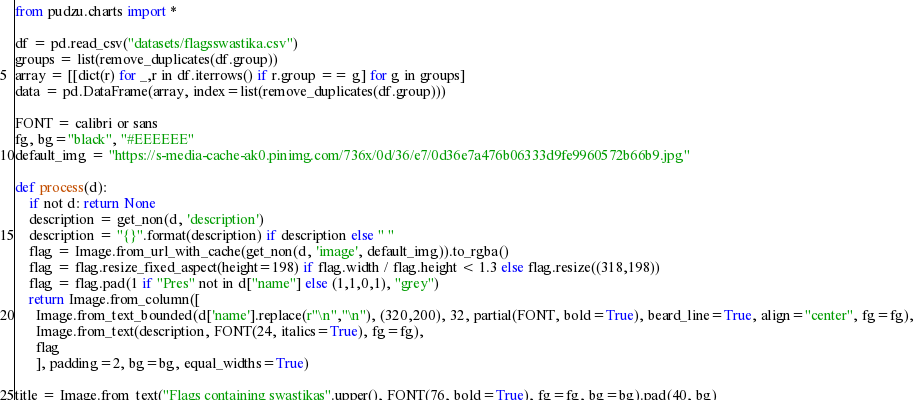Convert code to text. <code><loc_0><loc_0><loc_500><loc_500><_Python_>from pudzu.charts import *

df = pd.read_csv("datasets/flagsswastika.csv")
groups = list(remove_duplicates(df.group))
array = [[dict(r) for _,r in df.iterrows() if r.group == g] for g in groups]
data = pd.DataFrame(array, index=list(remove_duplicates(df.group)))

FONT = calibri or sans
fg, bg="black", "#EEEEEE"
default_img = "https://s-media-cache-ak0.pinimg.com/736x/0d/36/e7/0d36e7a476b06333d9fe9960572b66b9.jpg"

def process(d):
    if not d: return None
    description = get_non(d, 'description')
    description = "{}".format(description) if description else " "
    flag = Image.from_url_with_cache(get_non(d, 'image', default_img)).to_rgba()
    flag = flag.resize_fixed_aspect(height=198) if flag.width / flag.height < 1.3 else flag.resize((318,198))
    flag = flag.pad(1 if "Pres" not in d["name"] else (1,1,0,1), "grey") 
    return Image.from_column([
      Image.from_text_bounded(d['name'].replace(r"\n","\n"), (320,200), 32, partial(FONT, bold=True), beard_line=True, align="center", fg=fg),
      Image.from_text(description, FONT(24, italics=True), fg=fg),
      flag
      ], padding=2, bg=bg, equal_widths=True)

title = Image.from_text("Flags containing swastikas".upper(), FONT(76, bold=True), fg=fg, bg=bg).pad(40, bg)
</code> 